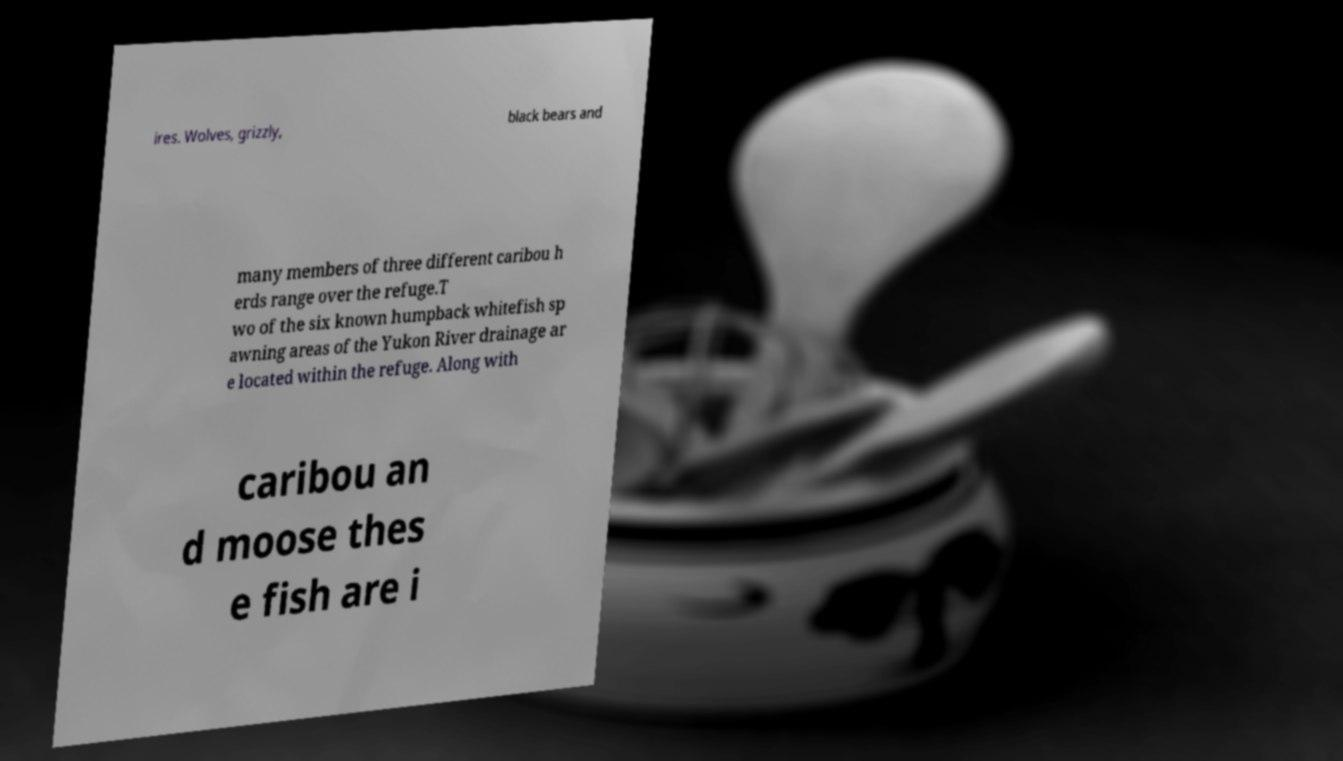Can you accurately transcribe the text from the provided image for me? ires. Wolves, grizzly, black bears and many members of three different caribou h erds range over the refuge.T wo of the six known humpback whitefish sp awning areas of the Yukon River drainage ar e located within the refuge. Along with caribou an d moose thes e fish are i 